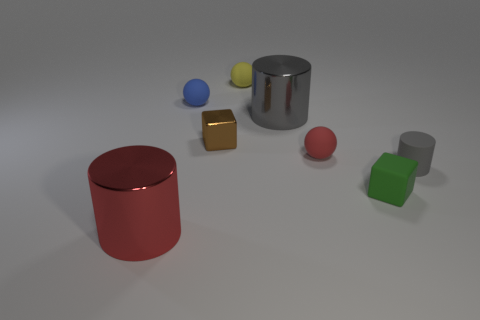Subtract all gray cylinders. How many cylinders are left? 1 Add 1 green cubes. How many objects exist? 9 Subtract all cylinders. How many objects are left? 5 Subtract 0 purple cylinders. How many objects are left? 8 Subtract all tiny balls. Subtract all small yellow spheres. How many objects are left? 4 Add 4 tiny yellow rubber balls. How many tiny yellow rubber balls are left? 5 Add 1 yellow rubber objects. How many yellow rubber objects exist? 2 